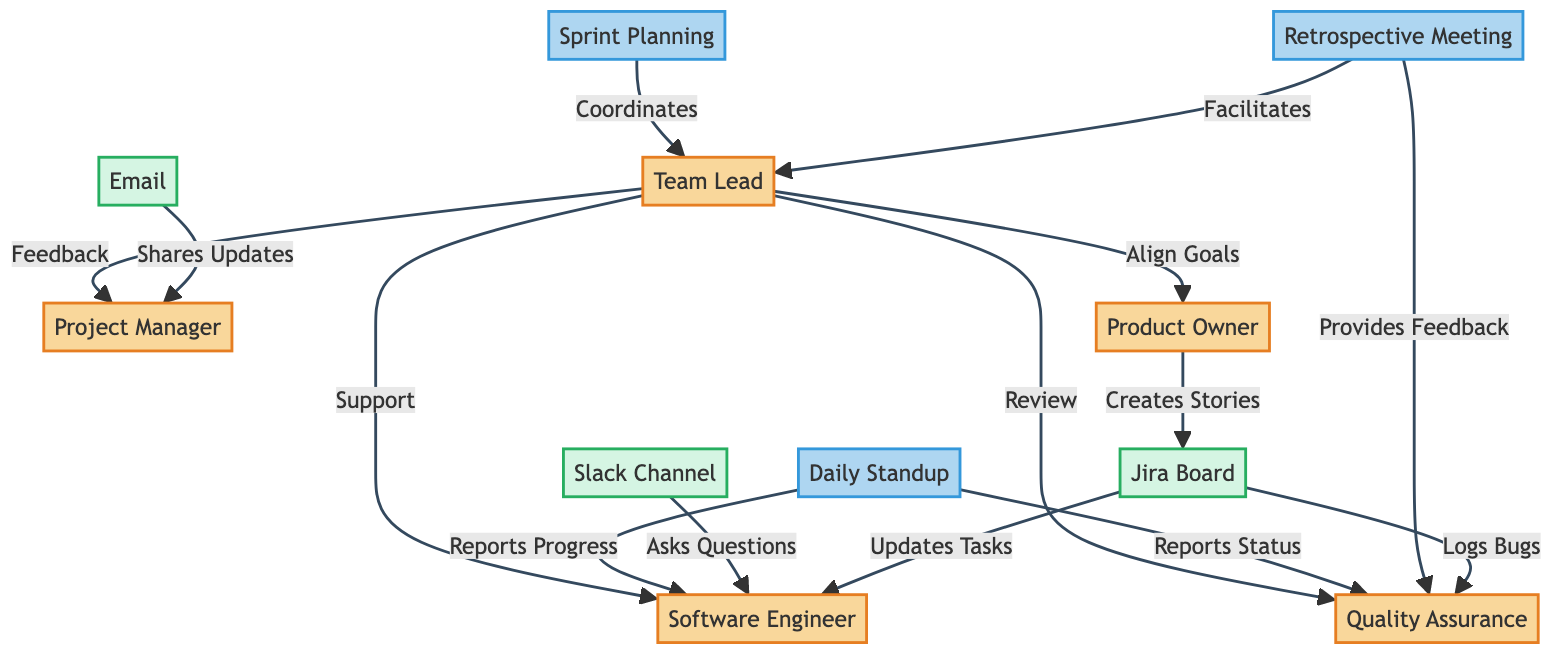What are the roles represented in the diagram? The diagram includes five roles: Team Lead, Project Manager, Software Engineer, Quality Assurance, and Product Owner.
Answer: Team Lead, Project Manager, Software Engineer, Quality Assurance, Product Owner How many communication tools are depicted in the diagram? There are three communication tools represented in the diagram: Slack Channel, Email, and Jira Board.
Answer: 3 What type of feedback does the Team Lead provide to the Project Manager? The Team Lead provides "Feedback" to the Project Manager, indicating a communication line focused on giving insights or evaluations.
Answer: Feedback Which event involves reporting progress by the Software Engineer? The "Daily Standup" is the event where the Software Engineer reports progress, as indicated in the diagram's participation links.
Answer: Daily Standup What is the primary purpose of the Retrospective Meeting involving Quality Assurance? In the Retrospective Meeting, Quality Assurance "Provides Feedback," indicating a role in reflecting on past works during discussions.
Answer: Provides Feedback How does the Product Owner interact with the Jira Board? The Product Owner "Creates Stories" on the Jira Board, showing their involvement in defining tasks and requirements for the team.
Answer: Creates Stories What type of communication does the Team Lead provide to the Software Engineer? The Team Lead provides "Support" to the Software Engineer, indicating a supportive communication approach towards the development work.
Answer: Support Which communication tool do Software Engineers use to ask questions? Software Engineers use the "Slack Channel" to ask questions, showing a real-time communication mechanism for queries.
Answer: Slack Channel How many feedback loops are there from the Team Lead? There are four feedback loops from the Team Lead, directed towards the Project Manager, Software Engineer, Quality Assurance, and Product Owner—indicating diverse communication points.
Answer: 4 